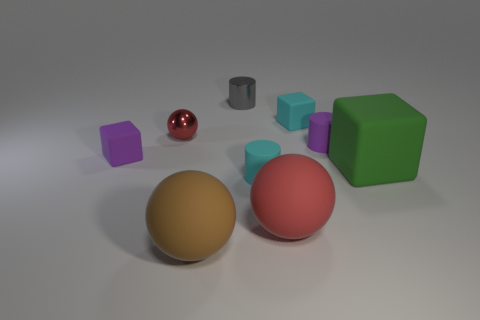How might the differences in texture between the objects influence our perception of them? The differences in texture can have a significant impact on our perception. The glossy texture of the red spheres reflects light, giving them a shiny appearance that may suggest smoothness and a high-quality finish. In contrast, the matte surfaces of the gold sphere and the green cube absorb light, resulting in a muted, soft look that might be perceived as more natural or organic. These textural contrasts can affect the visual weight and tactile expectations we associate with the objects. 